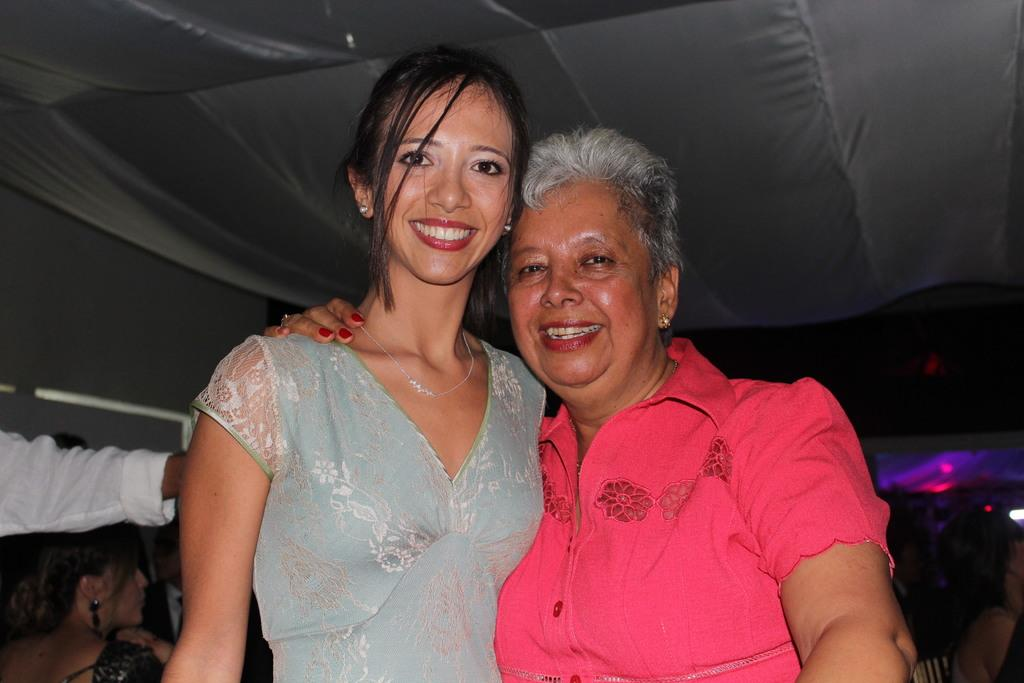How many people are in the image? There are persons in the image, but the exact number is not specified. What are the persons wearing? The persons are wearing clothes. What structure can be seen at the top of the image? There is a tent at the top of the image. What type of growth can be seen on the persons in the image? There is no mention of any growth on the persons in the image, so it is not possible to answer a question about growth in this context. 